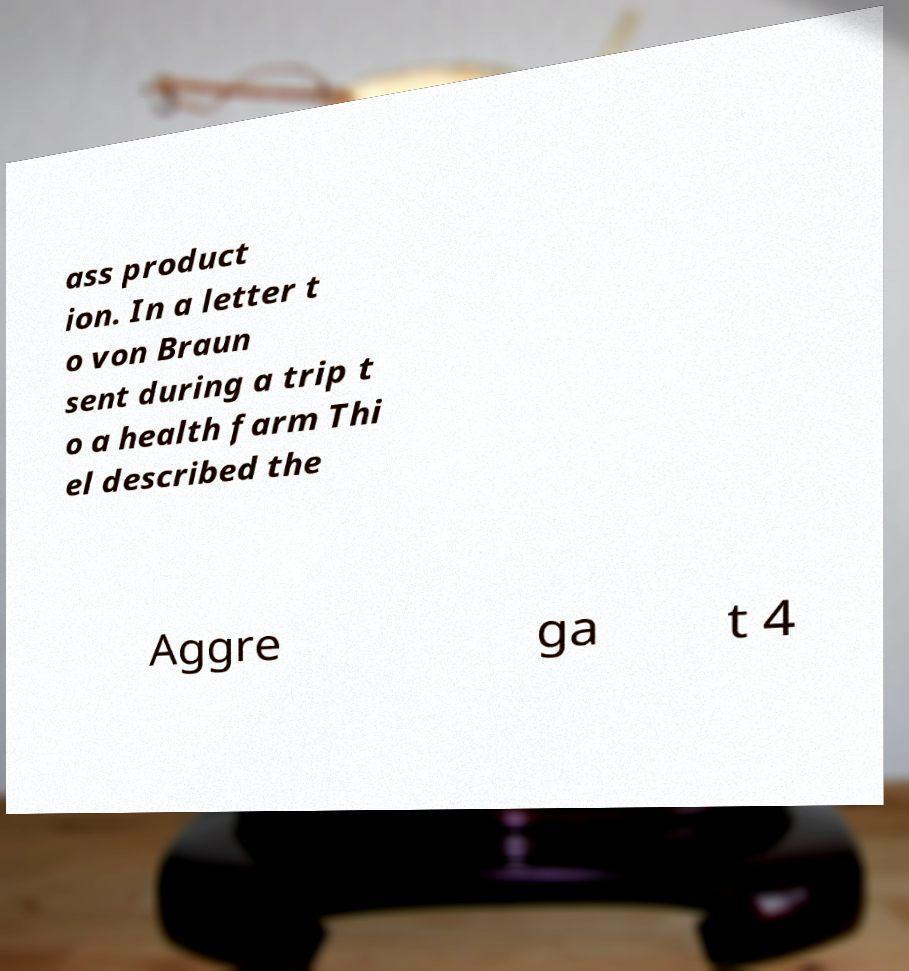What messages or text are displayed in this image? I need them in a readable, typed format. ass product ion. In a letter t o von Braun sent during a trip t o a health farm Thi el described the Aggre ga t 4 